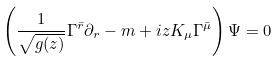<formula> <loc_0><loc_0><loc_500><loc_500>\left ( \frac { 1 } { \sqrt { g ( z ) } } \Gamma ^ { \bar { r } } \partial _ { r } - m + i z K _ { \mu } \Gamma ^ { \bar { \mu } } \right ) \Psi = 0</formula> 